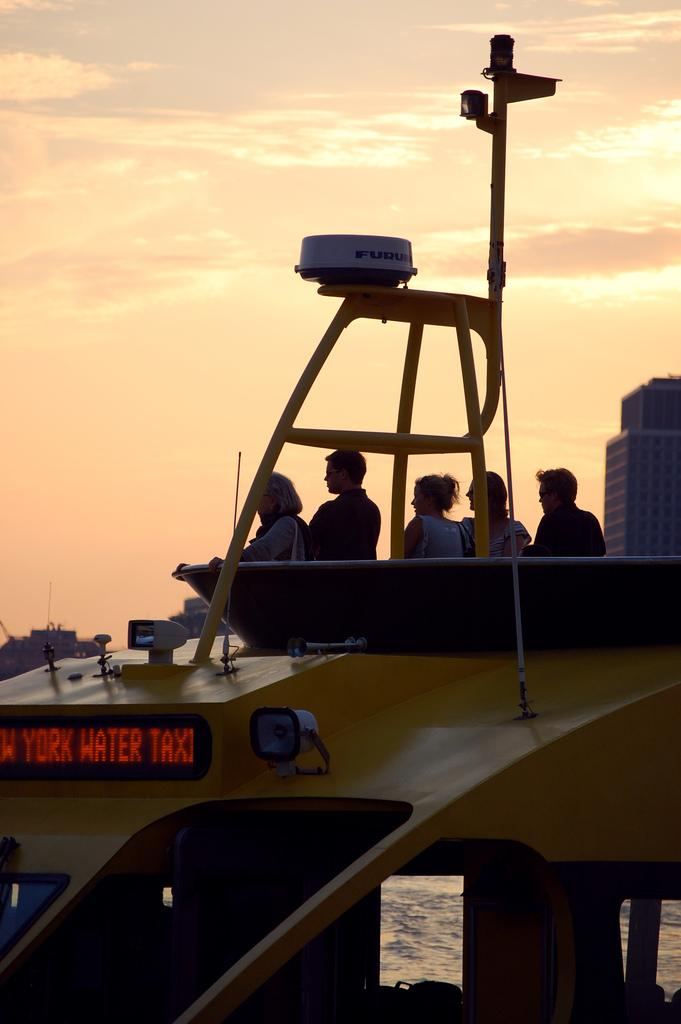What is the main subject of the image? The main subject of the image is a boat. Are there any people present in the image? Yes, there are people in the image. What type of electronic device can be seen in the image? There is a digital board in the image. What natural element is visible in the image? Water is visible in the image. What type of man-made structures can be seen in the image? There are buildings in the image. How would you describe the weather in the image? The sky is cloudy in the image. Can you describe any other objects present in the image? Yes, there are objects in the image. What type of soap is being used by the people in the image? There is no soap present in the image; it features a boat, people, a digital board, water, buildings, and a cloudy sky. 